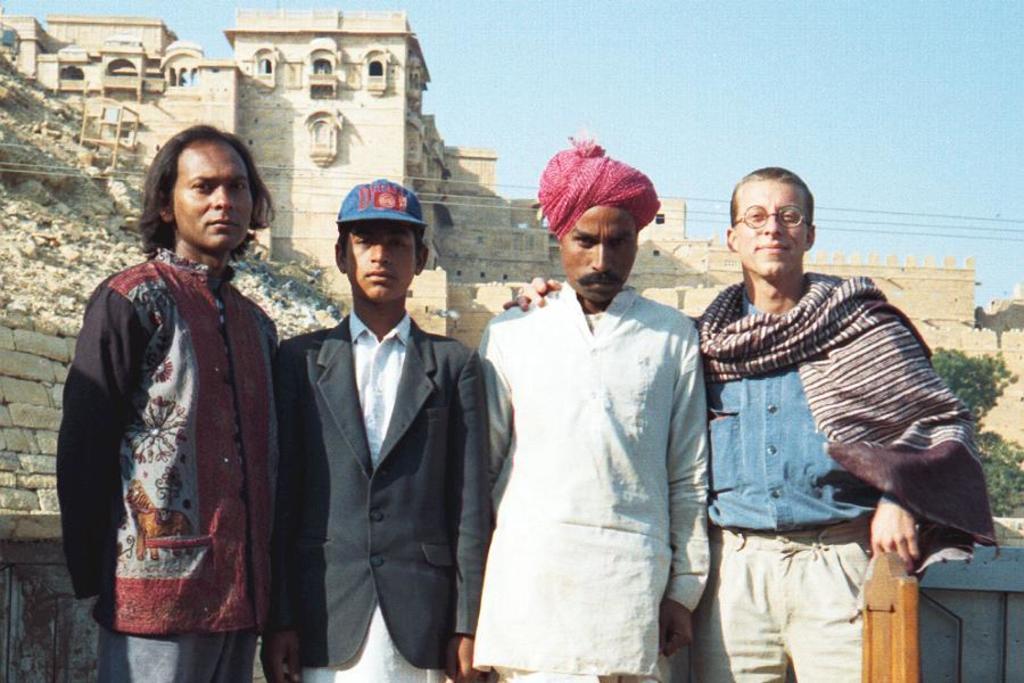Please provide a concise description of this image. In the image in the center we can see four people were standing and they were smiling,which we can see on their faces. And we can see two persons were wearing hat. In the background we can see the sky,building,wall,fence,trees,stones etc. 